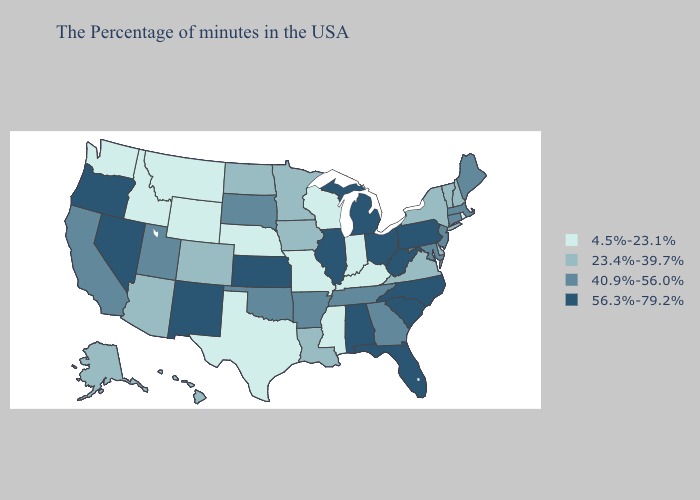Does the map have missing data?
Concise answer only. No. Among the states that border Louisiana , does Texas have the highest value?
Write a very short answer. No. Name the states that have a value in the range 40.9%-56.0%?
Short answer required. Maine, Massachusetts, Connecticut, New Jersey, Maryland, Georgia, Tennessee, Arkansas, Oklahoma, South Dakota, Utah, California. Does Ohio have the highest value in the MidWest?
Answer briefly. Yes. Name the states that have a value in the range 40.9%-56.0%?
Concise answer only. Maine, Massachusetts, Connecticut, New Jersey, Maryland, Georgia, Tennessee, Arkansas, Oklahoma, South Dakota, Utah, California. Does Missouri have the lowest value in the USA?
Be succinct. Yes. Name the states that have a value in the range 56.3%-79.2%?
Concise answer only. Pennsylvania, North Carolina, South Carolina, West Virginia, Ohio, Florida, Michigan, Alabama, Illinois, Kansas, New Mexico, Nevada, Oregon. What is the highest value in the USA?
Short answer required. 56.3%-79.2%. Among the states that border New Mexico , which have the highest value?
Answer briefly. Oklahoma, Utah. Does Illinois have a higher value than Michigan?
Write a very short answer. No. Does Connecticut have the lowest value in the Northeast?
Give a very brief answer. No. Does Missouri have the lowest value in the USA?
Give a very brief answer. Yes. Name the states that have a value in the range 4.5%-23.1%?
Quick response, please. Rhode Island, Kentucky, Indiana, Wisconsin, Mississippi, Missouri, Nebraska, Texas, Wyoming, Montana, Idaho, Washington. What is the highest value in states that border New Jersey?
Keep it brief. 56.3%-79.2%. Name the states that have a value in the range 4.5%-23.1%?
Be succinct. Rhode Island, Kentucky, Indiana, Wisconsin, Mississippi, Missouri, Nebraska, Texas, Wyoming, Montana, Idaho, Washington. 